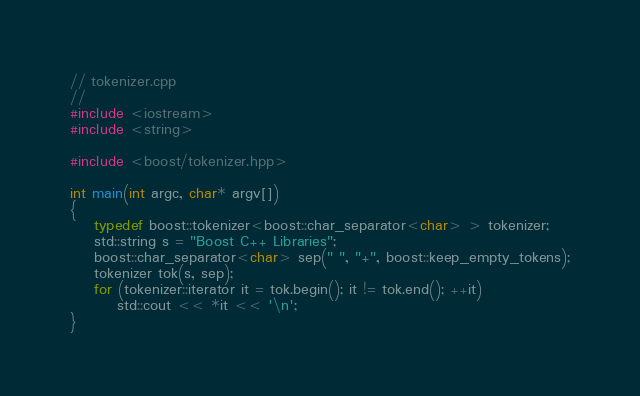<code> <loc_0><loc_0><loc_500><loc_500><_C++_>// tokenizer.cpp
//
#include <iostream>
#include <string>

#include <boost/tokenizer.hpp>

int main(int argc, char* argv[])
{
    typedef boost::tokenizer<boost::char_separator<char> > tokenizer;
    std::string s = "Boost C++ Libraries";
    boost::char_separator<char> sep(" ", "+", boost::keep_empty_tokens);
    tokenizer tok(s, sep);
    for (tokenizer::iterator it = tok.begin(); it != tok.end(); ++it)
        std::cout << *it << '\n';
}
</code> 